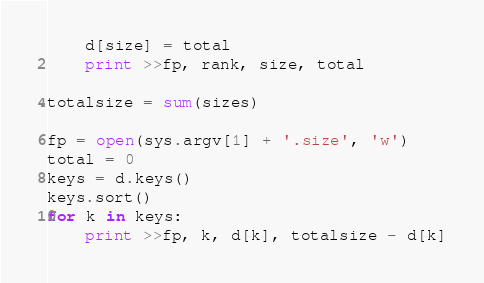Convert code to text. <code><loc_0><loc_0><loc_500><loc_500><_Python_>    d[size] = total
    print >>fp, rank, size, total

totalsize = sum(sizes)

fp = open(sys.argv[1] + '.size', 'w')
total = 0
keys = d.keys()
keys.sort()
for k in keys:
    print >>fp, k, d[k], totalsize - d[k]

</code> 